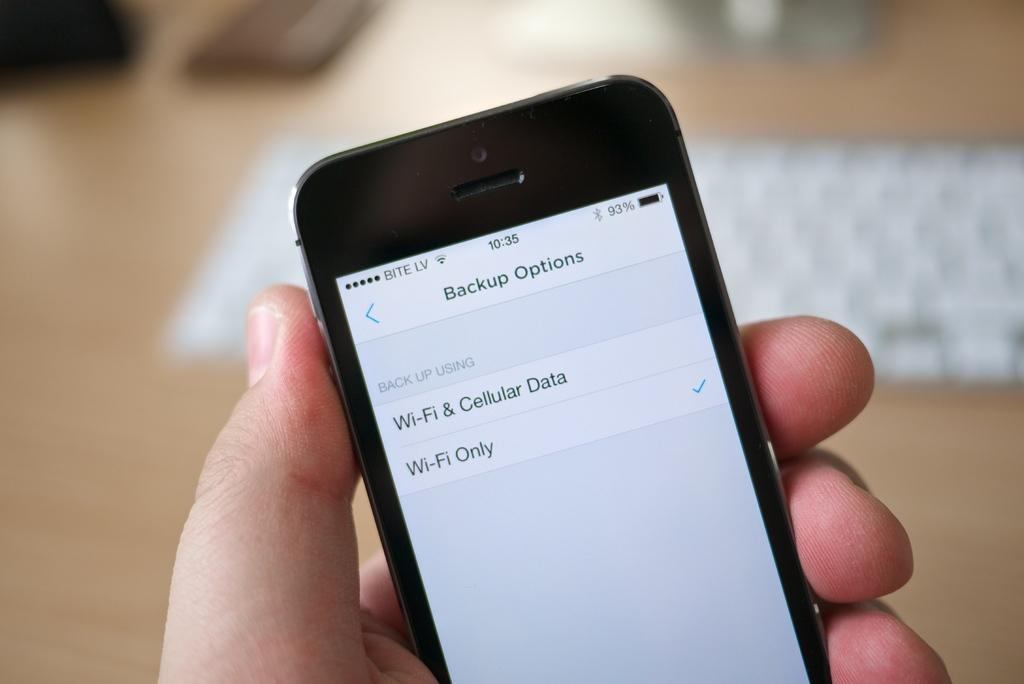Provide a one-sentence caption for the provided image. A cell phone shows two options for backups. 